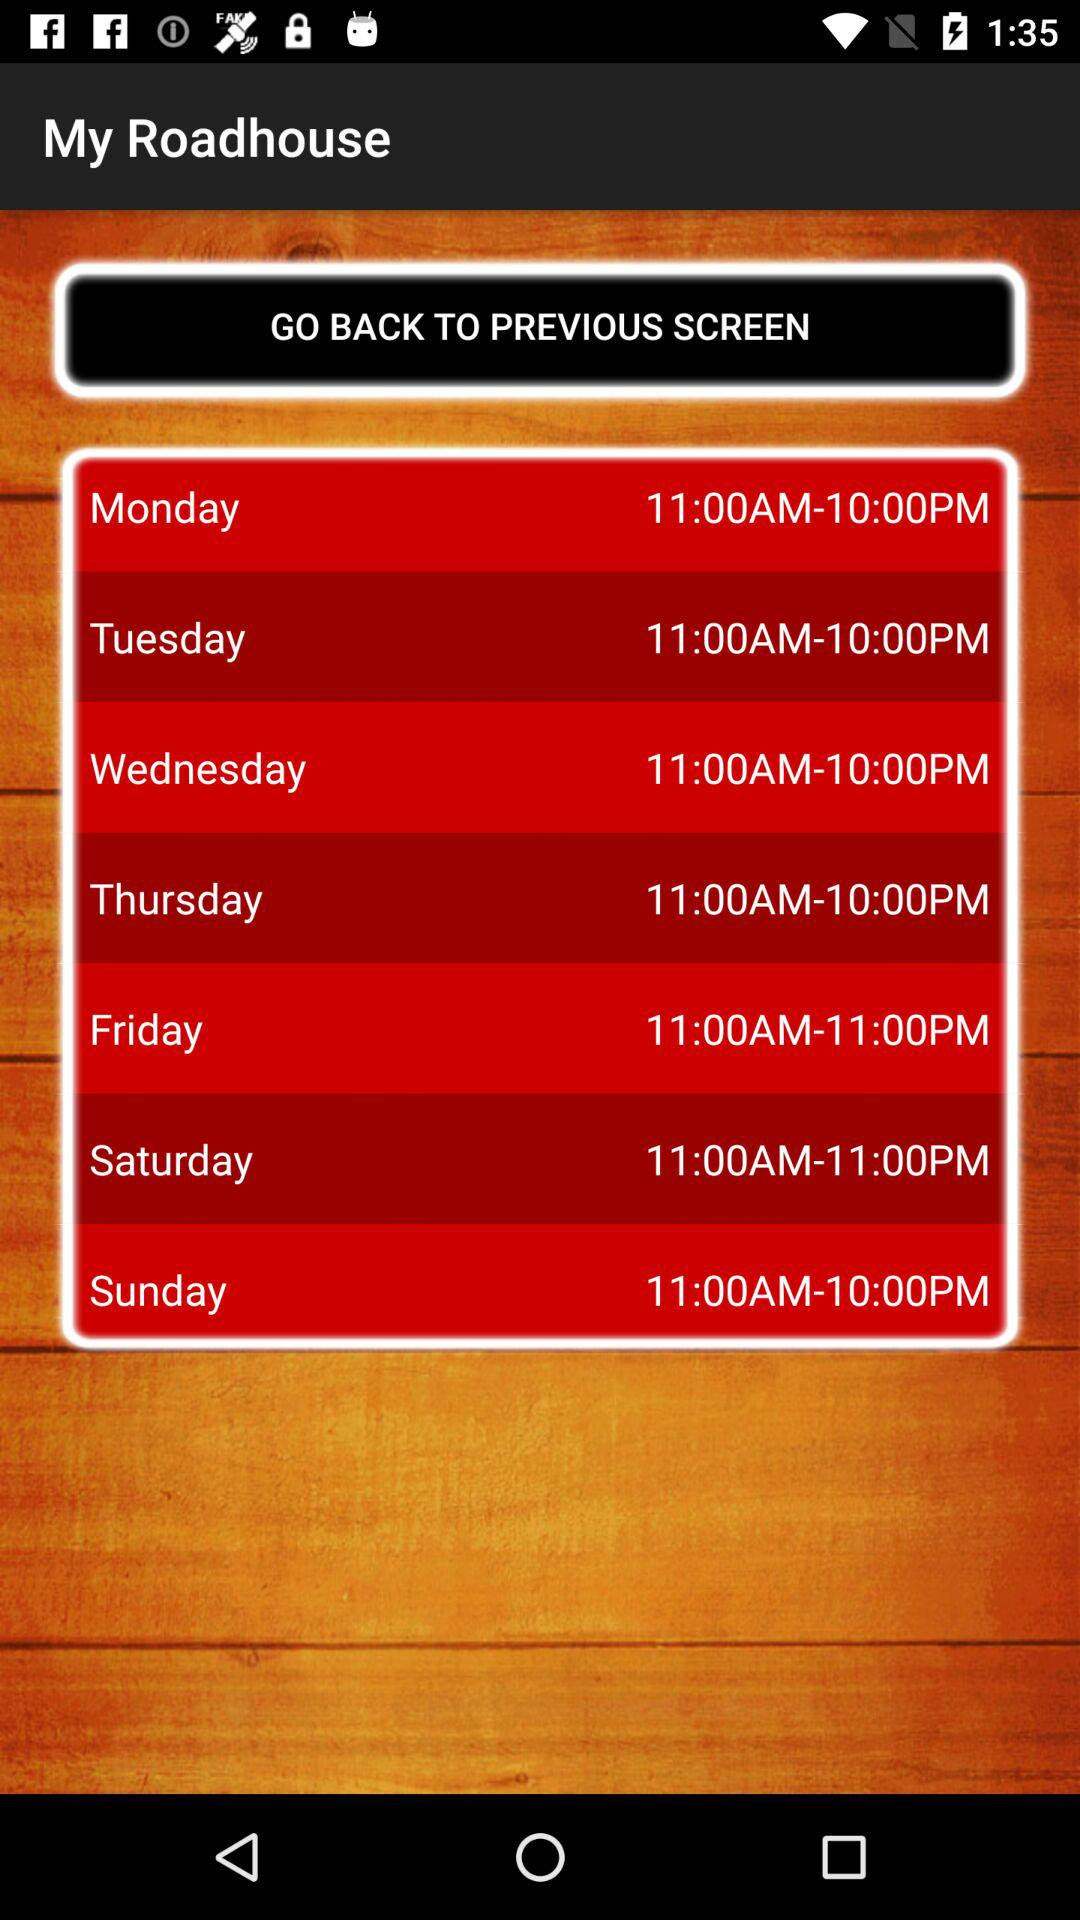What is the given time duration for Saturday? The time duration is from 11 a.m. to 11 p.m. 